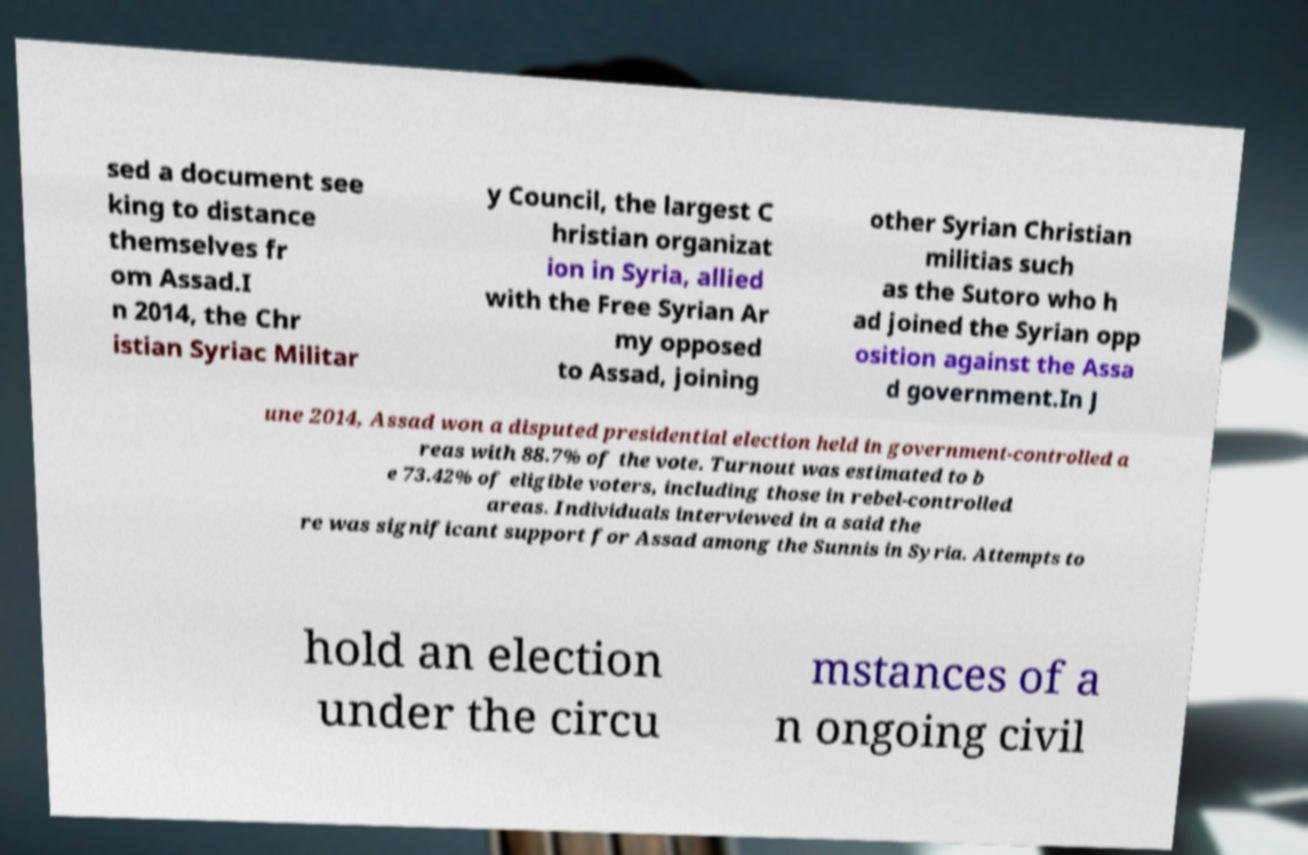Please read and relay the text visible in this image. What does it say? sed a document see king to distance themselves fr om Assad.I n 2014, the Chr istian Syriac Militar y Council, the largest C hristian organizat ion in Syria, allied with the Free Syrian Ar my opposed to Assad, joining other Syrian Christian militias such as the Sutoro who h ad joined the Syrian opp osition against the Assa d government.In J une 2014, Assad won a disputed presidential election held in government-controlled a reas with 88.7% of the vote. Turnout was estimated to b e 73.42% of eligible voters, including those in rebel-controlled areas. Individuals interviewed in a said the re was significant support for Assad among the Sunnis in Syria. Attempts to hold an election under the circu mstances of a n ongoing civil 